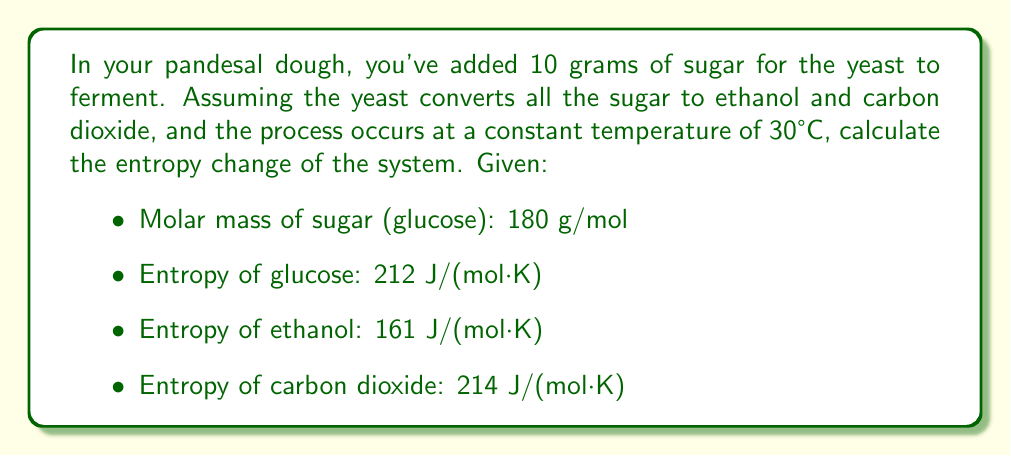Can you answer this question? Let's approach this step-by-step:

1) First, we need to determine the number of moles of glucose:
   $$n_{glucose} = \frac{10 \text{ g}}{180 \text{ g/mol}} = 0.0556 \text{ mol}$$

2) The fermentation reaction is:
   $$C_6H_{12}O_6 \rightarrow 2C_2H_5OH + 2CO_2$$

3) From the reaction, we can see that 1 mole of glucose produces 2 moles each of ethanol and CO2. So:
   $$n_{ethanol} = n_{CO_2} = 2 \times 0.0556 = 0.1112 \text{ mol}$$

4) Now, let's calculate the entropy change:
   $$\Delta S = S_{products} - S_{reactants}$$
   $$\Delta S = (n_{ethanol} \times S_{ethanol} + n_{CO_2} \times S_{CO_2}) - (n_{glucose} \times S_{glucose})$$

5) Substituting the values:
   $$\Delta S = (0.1112 \times 161 + 0.1112 \times 214) - (0.0556 \times 212)$$
   $$\Delta S = (17.9032 + 23.7968) - 11.7872$$
   $$\Delta S = 41.7 - 11.7872$$
   $$\Delta S = 29.9128 \text{ J/K}$$

6) Rounding to three significant figures:
   $$\Delta S = 29.9 \text{ J/K}$$
Answer: $29.9 \text{ J/K}$ 